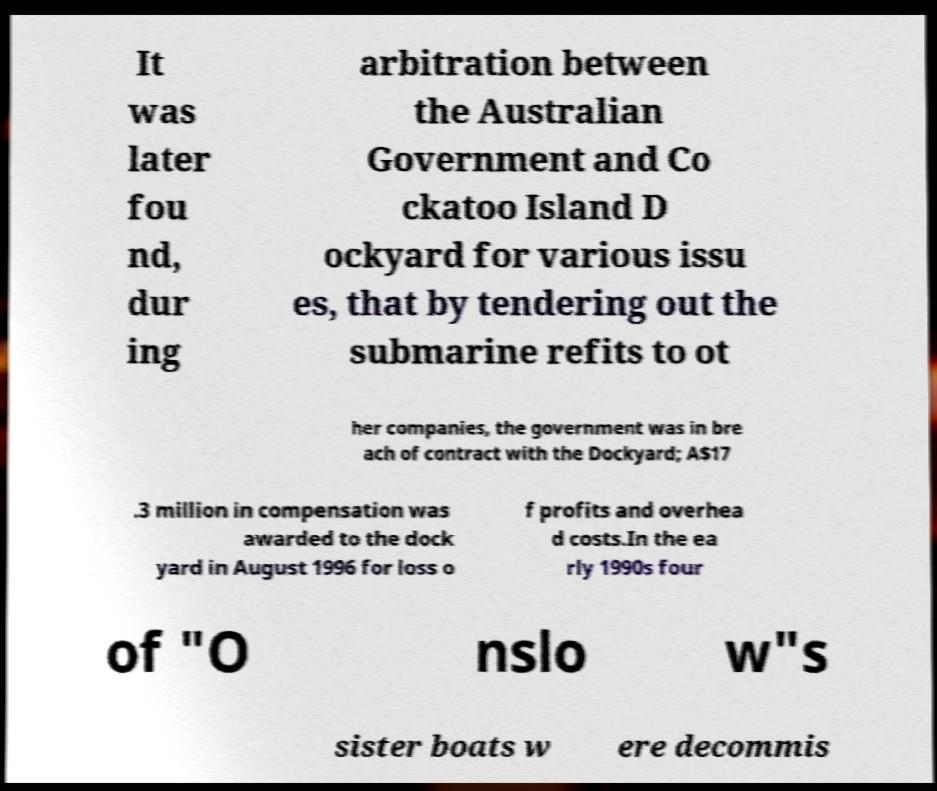Please identify and transcribe the text found in this image. It was later fou nd, dur ing arbitration between the Australian Government and Co ckatoo Island D ockyard for various issu es, that by tendering out the submarine refits to ot her companies, the government was in bre ach of contract with the Dockyard; A$17 .3 million in compensation was awarded to the dock yard in August 1996 for loss o f profits and overhea d costs.In the ea rly 1990s four of "O nslo w"s sister boats w ere decommis 